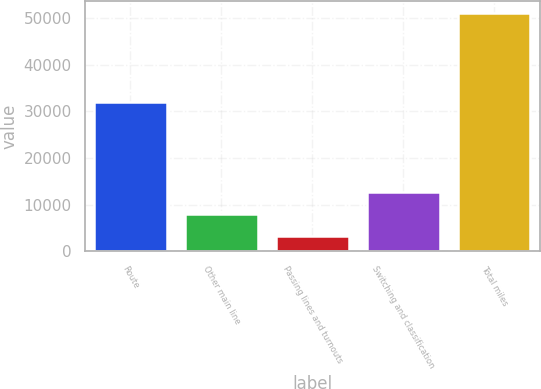<chart> <loc_0><loc_0><loc_500><loc_500><bar_chart><fcel>Route<fcel>Other main line<fcel>Passing lines and turnouts<fcel>Switching and classification<fcel>Total miles<nl><fcel>31974<fcel>7994.5<fcel>3197<fcel>12792<fcel>51172<nl></chart> 